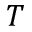Convert formula to latex. <formula><loc_0><loc_0><loc_500><loc_500>T</formula> 